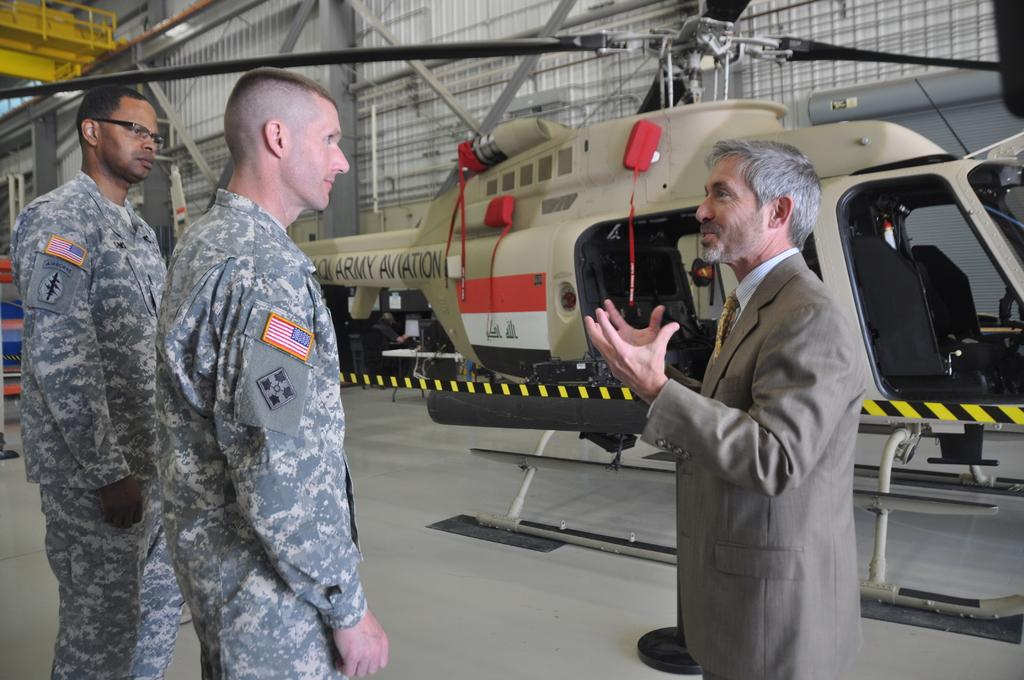How many persons are in the foreground of the image? There are three persons in the foreground of the image. What is one person doing in the image? One person is talking. What can be seen in the background of the image? There is a helicopter, poles, pillars, lights, a wall, and some objects in the background of the image. What type of tomatoes can be seen growing on the wall in the image? There are no tomatoes present in the image; the wall is part of the background and does not have any plants growing on it. 